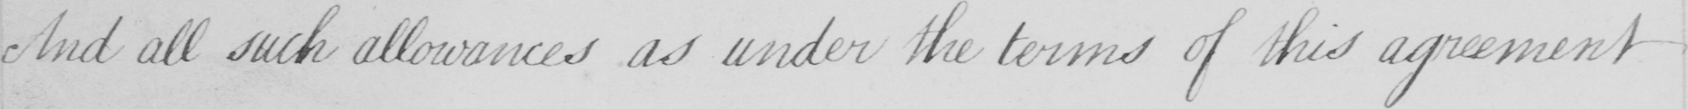Can you read and transcribe this handwriting? And all such allowances as under the terms of this agreement 